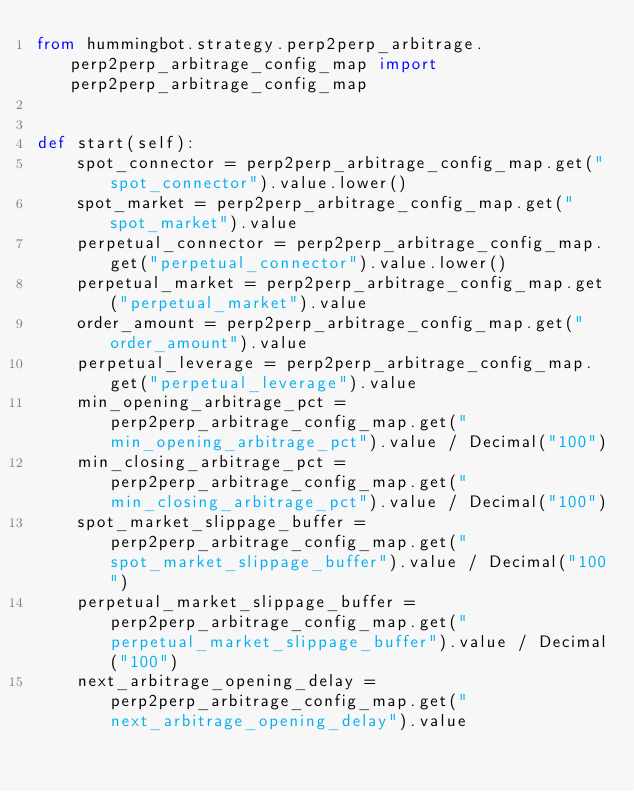<code> <loc_0><loc_0><loc_500><loc_500><_Python_>from hummingbot.strategy.perp2perp_arbitrage.perp2perp_arbitrage_config_map import perp2perp_arbitrage_config_map


def start(self):
    spot_connector = perp2perp_arbitrage_config_map.get("spot_connector").value.lower()
    spot_market = perp2perp_arbitrage_config_map.get("spot_market").value
    perpetual_connector = perp2perp_arbitrage_config_map.get("perpetual_connector").value.lower()
    perpetual_market = perp2perp_arbitrage_config_map.get("perpetual_market").value
    order_amount = perp2perp_arbitrage_config_map.get("order_amount").value
    perpetual_leverage = perp2perp_arbitrage_config_map.get("perpetual_leverage").value
    min_opening_arbitrage_pct = perp2perp_arbitrage_config_map.get("min_opening_arbitrage_pct").value / Decimal("100")
    min_closing_arbitrage_pct = perp2perp_arbitrage_config_map.get("min_closing_arbitrage_pct").value / Decimal("100")
    spot_market_slippage_buffer = perp2perp_arbitrage_config_map.get("spot_market_slippage_buffer").value / Decimal("100")
    perpetual_market_slippage_buffer = perp2perp_arbitrage_config_map.get("perpetual_market_slippage_buffer").value / Decimal("100")
    next_arbitrage_opening_delay = perp2perp_arbitrage_config_map.get("next_arbitrage_opening_delay").value
</code> 